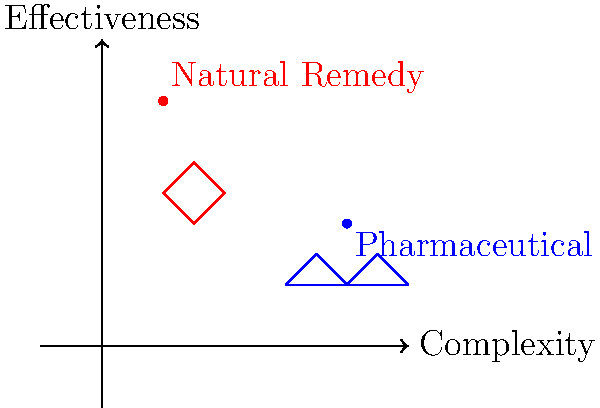Analyze the molecular structures and effectiveness of natural remedies versus pharmaceutical drugs as represented in the diagram. Which type of treatment appears to have a simpler molecular structure but potentially higher effectiveness based on the graph? Explain your reasoning considering the skepticism towards traditional Western medicine. To answer this question, we need to analyze the diagram step-by-step:

1. The x-axis represents complexity, with values increasing from left to right.
2. The y-axis represents effectiveness, with values increasing from bottom to top.
3. Two points are plotted on the graph:
   a. A red point labeled "Natural Remedy" at coordinates approximately (1,4)
   b. A blue point labeled "Pharmaceutical" at coordinates approximately (4,2)
4. Simple chemical structures are drawn near each point, with the natural remedy structure being simpler than the pharmaceutical structure.

Analyzing these elements:

1. Complexity: The natural remedy is positioned further left on the x-axis, indicating a lower complexity compared to the pharmaceutical drug.
2. Effectiveness: The natural remedy is positioned higher on the y-axis, suggesting a higher effectiveness compared to the pharmaceutical drug.
3. Molecular structure: The diagram shows a simpler structure for the natural remedy compared to the more complex structure of the pharmaceutical drug.

Considering the skepticism towards traditional Western medicine, this diagram supports the idea that natural remedies can be both simpler in structure and potentially more effective than pharmaceutical drugs. This aligns with the perspective that traditional, natural treatments may offer benefits without the complexity and potential side effects associated with synthetic pharmaceuticals.

However, it's important to note that this is a simplified representation and real-world scenarios may be more complex. The effectiveness and safety of any treatment should be evaluated based on scientific evidence and individual circumstances.
Answer: Natural remedies; simpler structure, higher effectiveness on graph 